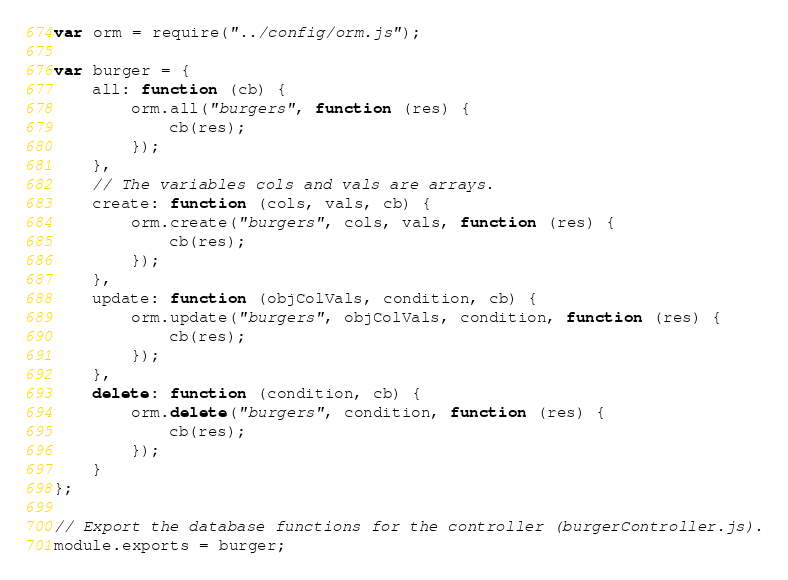<code> <loc_0><loc_0><loc_500><loc_500><_JavaScript_>var orm = require("../config/orm.js");

var burger = {
    all: function (cb) {
        orm.all("burgers", function (res) {
            cb(res);
        });
    },
    // The variables cols and vals are arrays.
    create: function (cols, vals, cb) {
        orm.create("burgers", cols, vals, function (res) {
            cb(res);
        });
    },
    update: function (objColVals, condition, cb) {
        orm.update("burgers", objColVals, condition, function (res) {
            cb(res);
        });
    },
    delete: function (condition, cb) {
        orm.delete("burgers", condition, function (res) {
            cb(res);
        });
    }
};

// Export the database functions for the controller (burgerController.js).
module.exports = burger;</code> 